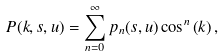<formula> <loc_0><loc_0><loc_500><loc_500>P ( k , s , u ) = \sum _ { n = 0 } ^ { \infty } p _ { n } ( s , u ) \cos ^ { n } \left ( k \right ) ,</formula> 